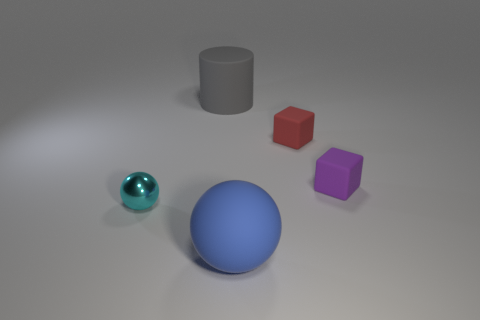Add 3 big gray cylinders. How many objects exist? 8 Subtract all cylinders. How many objects are left? 4 Subtract 0 red cylinders. How many objects are left? 5 Subtract all big balls. Subtract all yellow shiny objects. How many objects are left? 4 Add 1 blue rubber things. How many blue rubber things are left? 2 Add 2 large red shiny cubes. How many large red shiny cubes exist? 2 